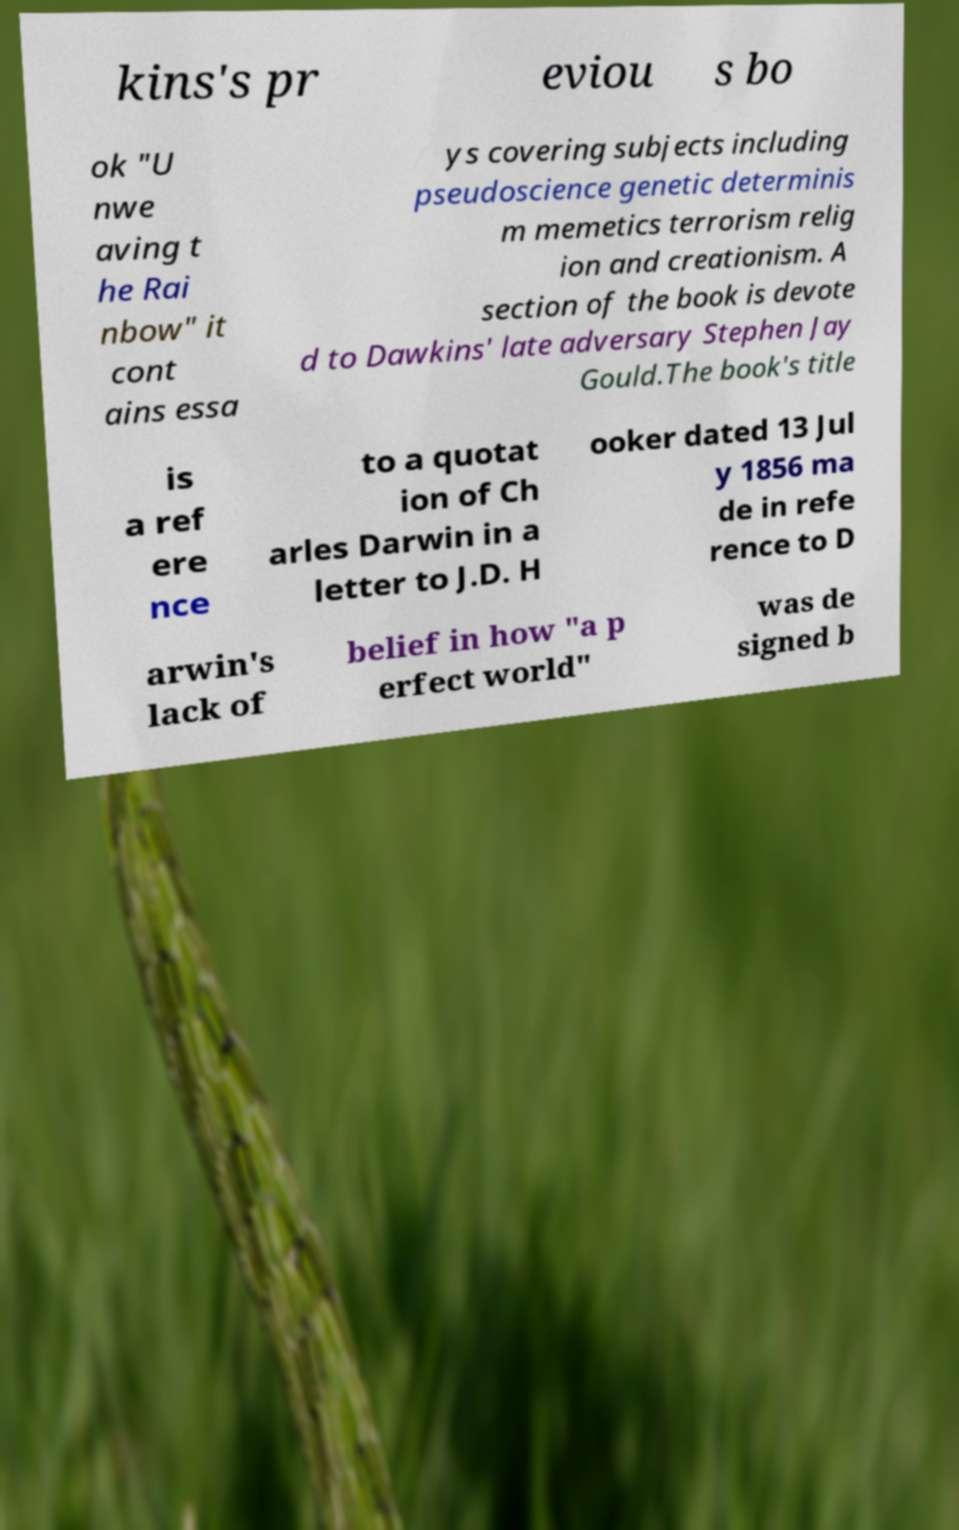What messages or text are displayed in this image? I need them in a readable, typed format. kins's pr eviou s bo ok "U nwe aving t he Rai nbow" it cont ains essa ys covering subjects including pseudoscience genetic determinis m memetics terrorism relig ion and creationism. A section of the book is devote d to Dawkins' late adversary Stephen Jay Gould.The book's title is a ref ere nce to a quotat ion of Ch arles Darwin in a letter to J.D. H ooker dated 13 Jul y 1856 ma de in refe rence to D arwin's lack of belief in how "a p erfect world" was de signed b 